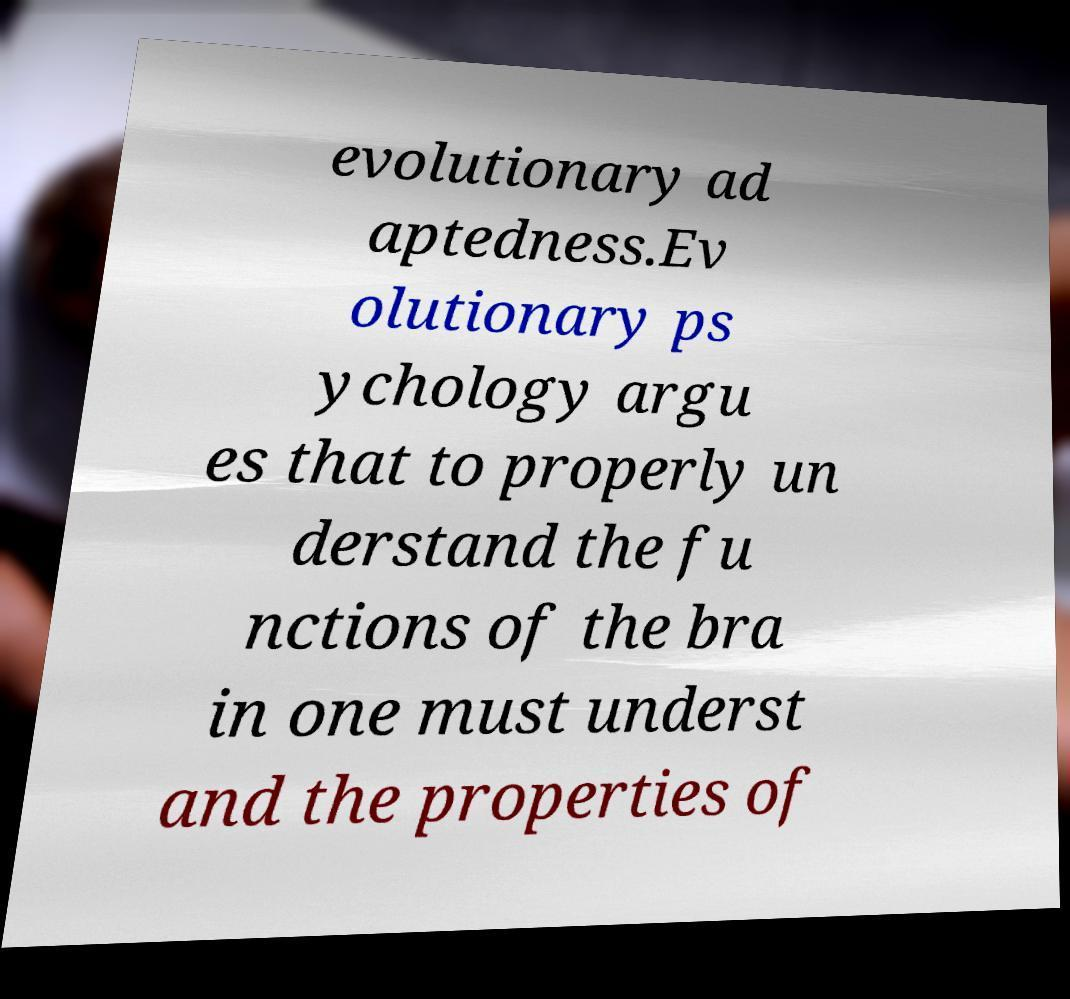I need the written content from this picture converted into text. Can you do that? evolutionary ad aptedness.Ev olutionary ps ychology argu es that to properly un derstand the fu nctions of the bra in one must underst and the properties of 